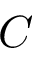Convert formula to latex. <formula><loc_0><loc_0><loc_500><loc_500>C</formula> 